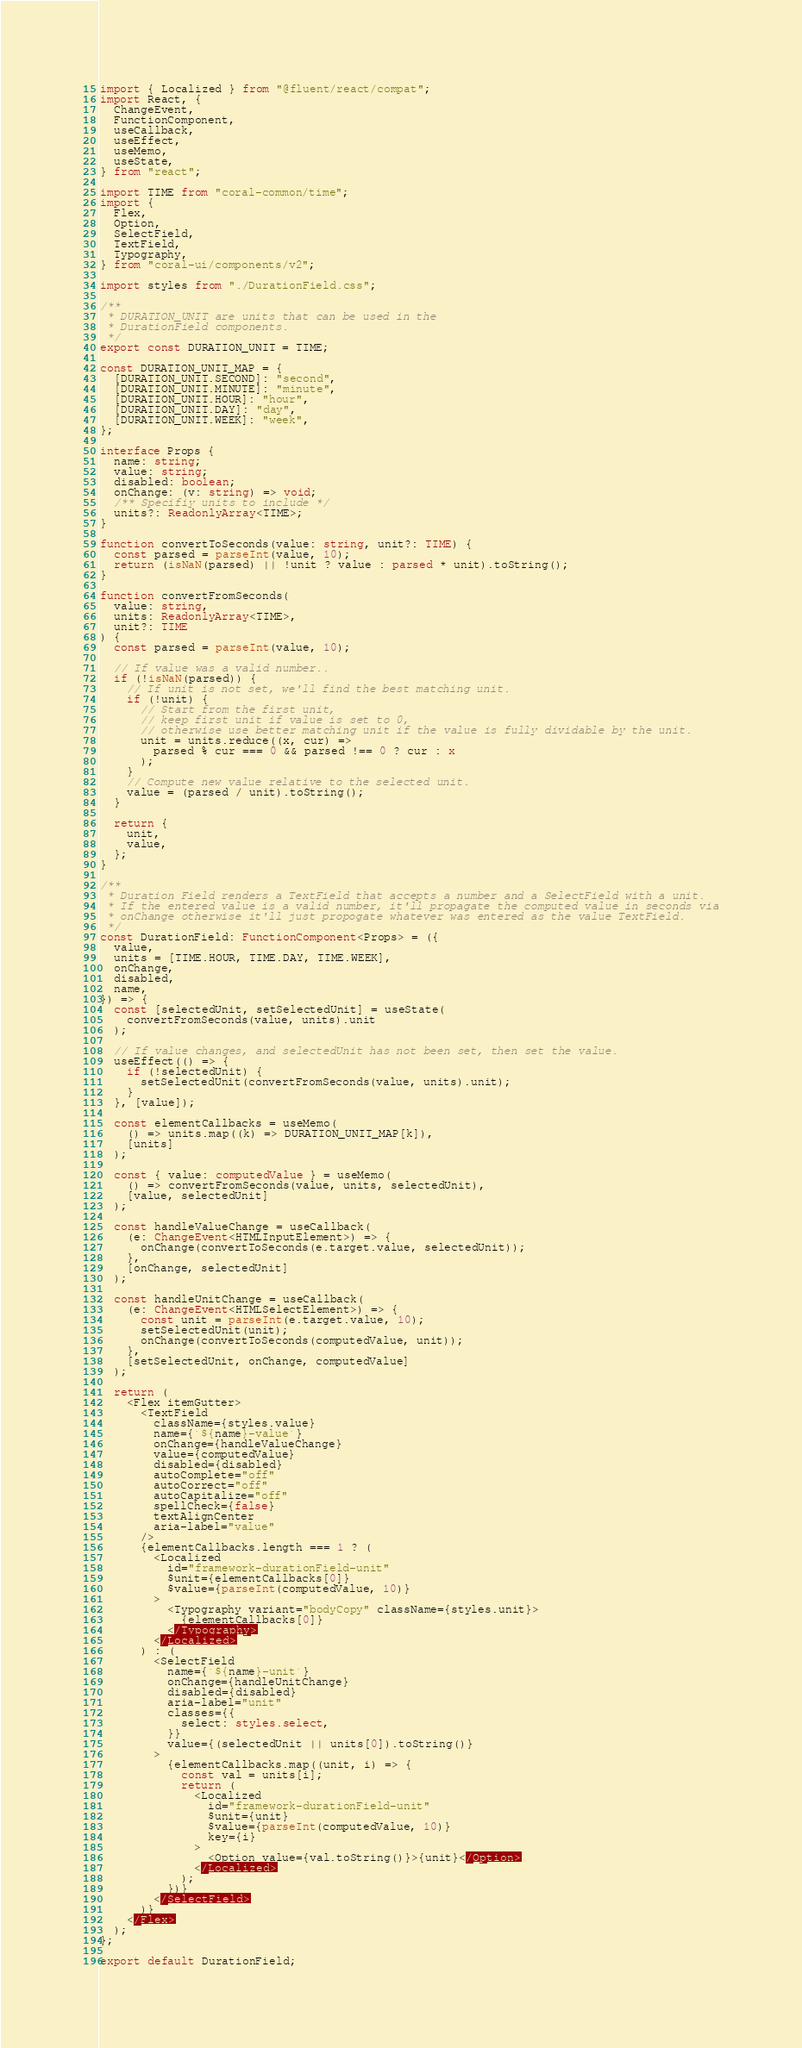Convert code to text. <code><loc_0><loc_0><loc_500><loc_500><_TypeScript_>import { Localized } from "@fluent/react/compat";
import React, {
  ChangeEvent,
  FunctionComponent,
  useCallback,
  useEffect,
  useMemo,
  useState,
} from "react";

import TIME from "coral-common/time";
import {
  Flex,
  Option,
  SelectField,
  TextField,
  Typography,
} from "coral-ui/components/v2";

import styles from "./DurationField.css";

/**
 * DURATION_UNIT are units that can be used in the
 * DurationField components.
 */
export const DURATION_UNIT = TIME;

const DURATION_UNIT_MAP = {
  [DURATION_UNIT.SECOND]: "second",
  [DURATION_UNIT.MINUTE]: "minute",
  [DURATION_UNIT.HOUR]: "hour",
  [DURATION_UNIT.DAY]: "day",
  [DURATION_UNIT.WEEK]: "week",
};

interface Props {
  name: string;
  value: string;
  disabled: boolean;
  onChange: (v: string) => void;
  /** Specifiy units to include */
  units?: ReadonlyArray<TIME>;
}

function convertToSeconds(value: string, unit?: TIME) {
  const parsed = parseInt(value, 10);
  return (isNaN(parsed) || !unit ? value : parsed * unit).toString();
}

function convertFromSeconds(
  value: string,
  units: ReadonlyArray<TIME>,
  unit?: TIME
) {
  const parsed = parseInt(value, 10);

  // If value was a valid number..
  if (!isNaN(parsed)) {
    // If unit is not set, we'll find the best matching unit.
    if (!unit) {
      // Start from the first unit,
      // keep first unit if value is set to 0,
      // otherwise use better matching unit if the value is fully dividable by the unit.
      unit = units.reduce((x, cur) =>
        parsed % cur === 0 && parsed !== 0 ? cur : x
      );
    }
    // Compute new value relative to the selected unit.
    value = (parsed / unit).toString();
  }

  return {
    unit,
    value,
  };
}

/**
 * Duration Field renders a TextField that accepts a number and a SelectField with a unit.
 * If the entered value is a valid number, it'll propagate the computed value in seconds via
 * onChange otherwise it'll just propogate whatever was entered as the value TextField.
 */
const DurationField: FunctionComponent<Props> = ({
  value,
  units = [TIME.HOUR, TIME.DAY, TIME.WEEK],
  onChange,
  disabled,
  name,
}) => {
  const [selectedUnit, setSelectedUnit] = useState(
    convertFromSeconds(value, units).unit
  );

  // If value changes, and selectedUnit has not been set, then set the value.
  useEffect(() => {
    if (!selectedUnit) {
      setSelectedUnit(convertFromSeconds(value, units).unit);
    }
  }, [value]);

  const elementCallbacks = useMemo(
    () => units.map((k) => DURATION_UNIT_MAP[k]),
    [units]
  );

  const { value: computedValue } = useMemo(
    () => convertFromSeconds(value, units, selectedUnit),
    [value, selectedUnit]
  );

  const handleValueChange = useCallback(
    (e: ChangeEvent<HTMLInputElement>) => {
      onChange(convertToSeconds(e.target.value, selectedUnit));
    },
    [onChange, selectedUnit]
  );

  const handleUnitChange = useCallback(
    (e: ChangeEvent<HTMLSelectElement>) => {
      const unit = parseInt(e.target.value, 10);
      setSelectedUnit(unit);
      onChange(convertToSeconds(computedValue, unit));
    },
    [setSelectedUnit, onChange, computedValue]
  );

  return (
    <Flex itemGutter>
      <TextField
        className={styles.value}
        name={`${name}-value`}
        onChange={handleValueChange}
        value={computedValue}
        disabled={disabled}
        autoComplete="off"
        autoCorrect="off"
        autoCapitalize="off"
        spellCheck={false}
        textAlignCenter
        aria-label="value"
      />
      {elementCallbacks.length === 1 ? (
        <Localized
          id="framework-durationField-unit"
          $unit={elementCallbacks[0]}
          $value={parseInt(computedValue, 10)}
        >
          <Typography variant="bodyCopy" className={styles.unit}>
            {elementCallbacks[0]}
          </Typography>
        </Localized>
      ) : (
        <SelectField
          name={`${name}-unit`}
          onChange={handleUnitChange}
          disabled={disabled}
          aria-label="unit"
          classes={{
            select: styles.select,
          }}
          value={(selectedUnit || units[0]).toString()}
        >
          {elementCallbacks.map((unit, i) => {
            const val = units[i];
            return (
              <Localized
                id="framework-durationField-unit"
                $unit={unit}
                $value={parseInt(computedValue, 10)}
                key={i}
              >
                <Option value={val.toString()}>{unit}</Option>
              </Localized>
            );
          })}
        </SelectField>
      )}
    </Flex>
  );
};

export default DurationField;
</code> 